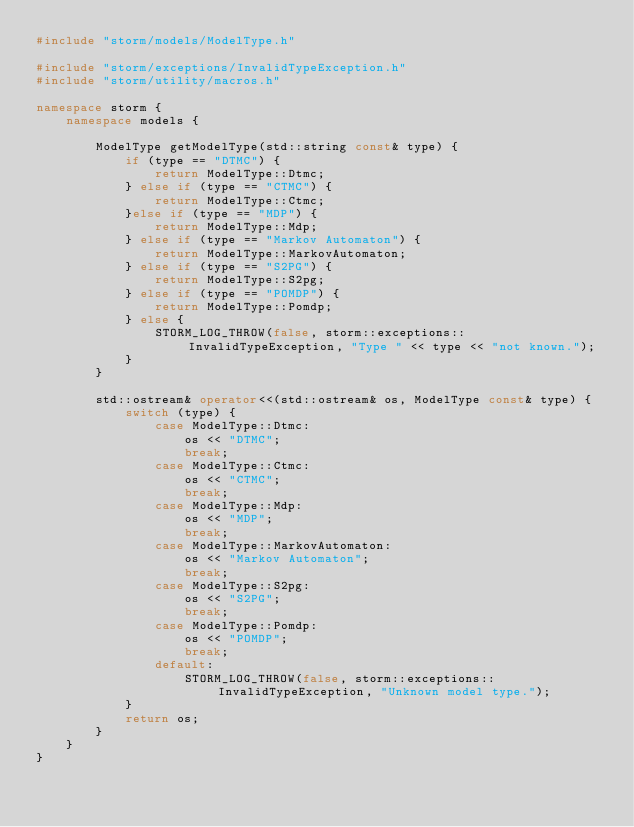Convert code to text. <code><loc_0><loc_0><loc_500><loc_500><_C++_>#include "storm/models/ModelType.h"

#include "storm/exceptions/InvalidTypeException.h"
#include "storm/utility/macros.h"

namespace storm {
    namespace models {

        ModelType getModelType(std::string const& type) {
            if (type == "DTMC") {
                return ModelType::Dtmc;
            } else if (type == "CTMC") {
                return ModelType::Ctmc;
            }else if (type == "MDP") {
                return ModelType::Mdp;
            } else if (type == "Markov Automaton") {
                return ModelType::MarkovAutomaton;
            } else if (type == "S2PG") {
                return ModelType::S2pg;
            } else if (type == "POMDP") {
                return ModelType::Pomdp;
            } else {
                STORM_LOG_THROW(false, storm::exceptions::InvalidTypeException, "Type " << type << "not known.");
            }
        }

        std::ostream& operator<<(std::ostream& os, ModelType const& type) {
            switch (type) {
                case ModelType::Dtmc:
                    os << "DTMC";
                    break;
                case ModelType::Ctmc:
                    os << "CTMC";
                    break;
                case ModelType::Mdp:
                    os << "MDP";
                    break;
                case ModelType::MarkovAutomaton:
                    os << "Markov Automaton";
                    break;
                case ModelType::S2pg:
                    os << "S2PG";
                    break;
                case ModelType::Pomdp:
                    os << "POMDP";
                    break;
                default:
                    STORM_LOG_THROW(false, storm::exceptions::InvalidTypeException, "Unknown model type.");
            }
            return os;
        }
    }
}
</code> 